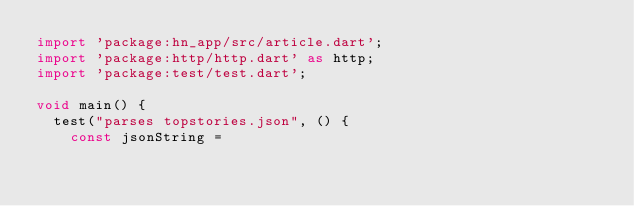<code> <loc_0><loc_0><loc_500><loc_500><_Dart_>import 'package:hn_app/src/article.dart';
import 'package:http/http.dart' as http;
import 'package:test/test.dart';

void main() {
  test("parses topstories.json", () {
    const jsonString =</code> 